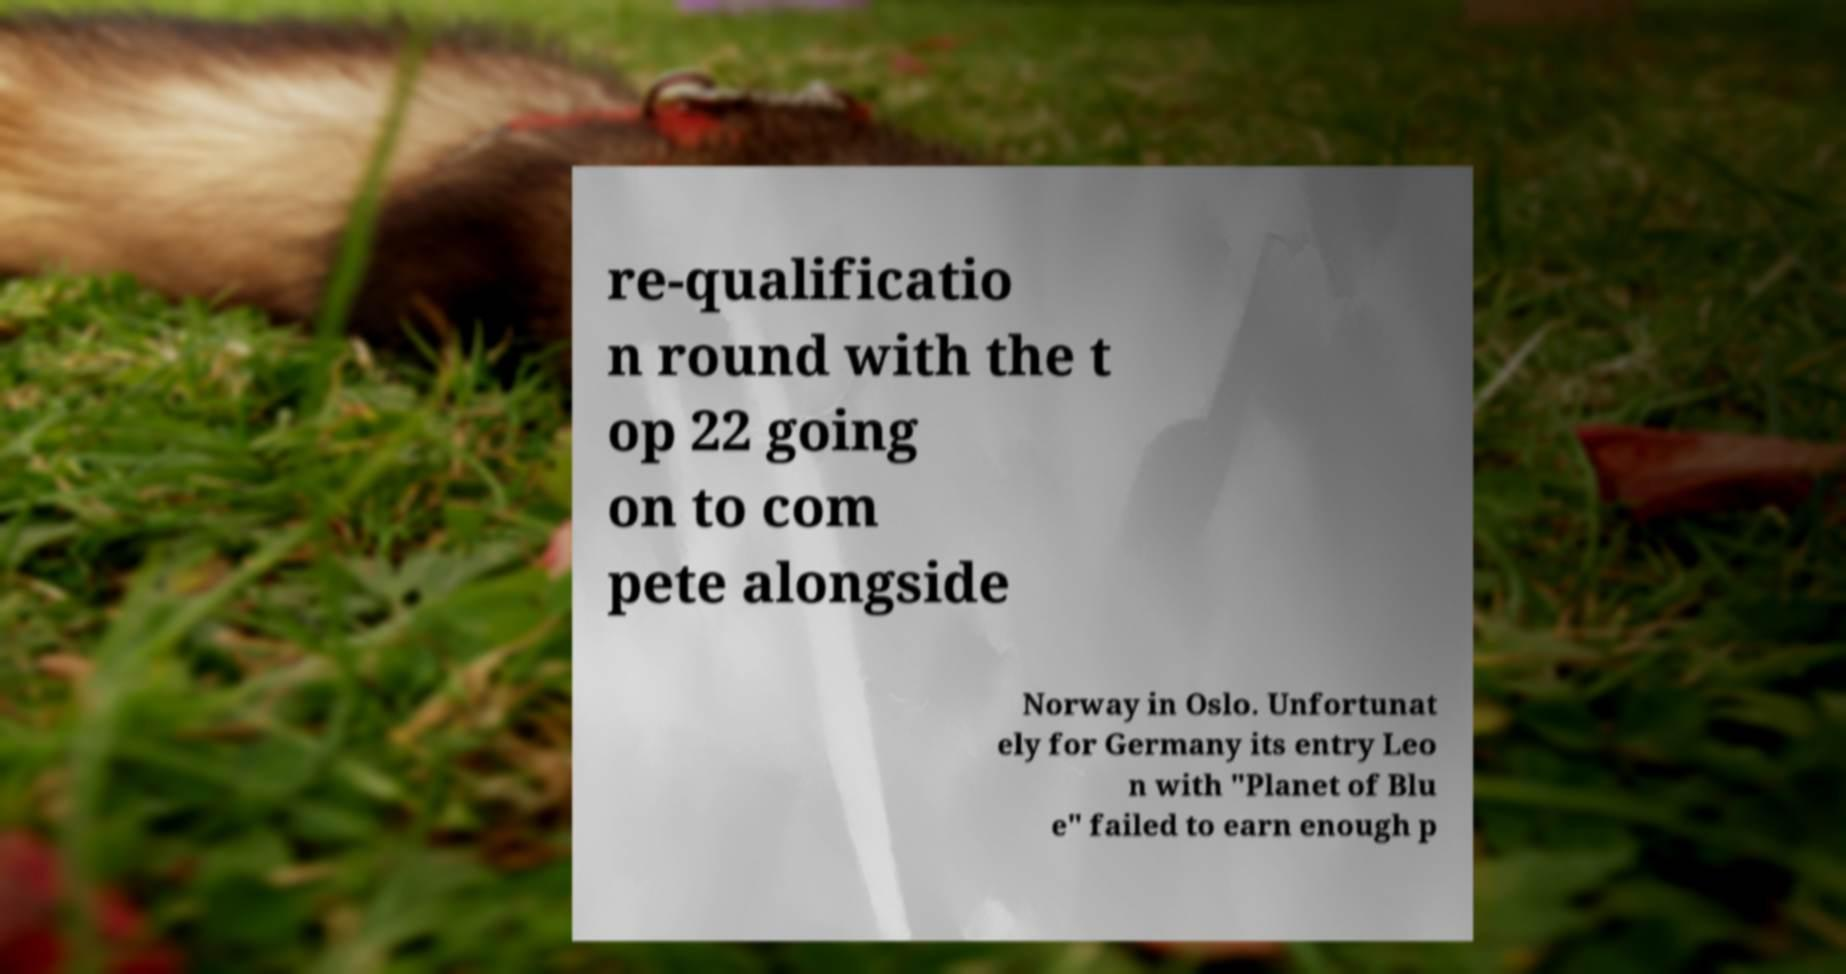Please read and relay the text visible in this image. What does it say? re-qualificatio n round with the t op 22 going on to com pete alongside Norway in Oslo. Unfortunat ely for Germany its entry Leo n with "Planet of Blu e" failed to earn enough p 